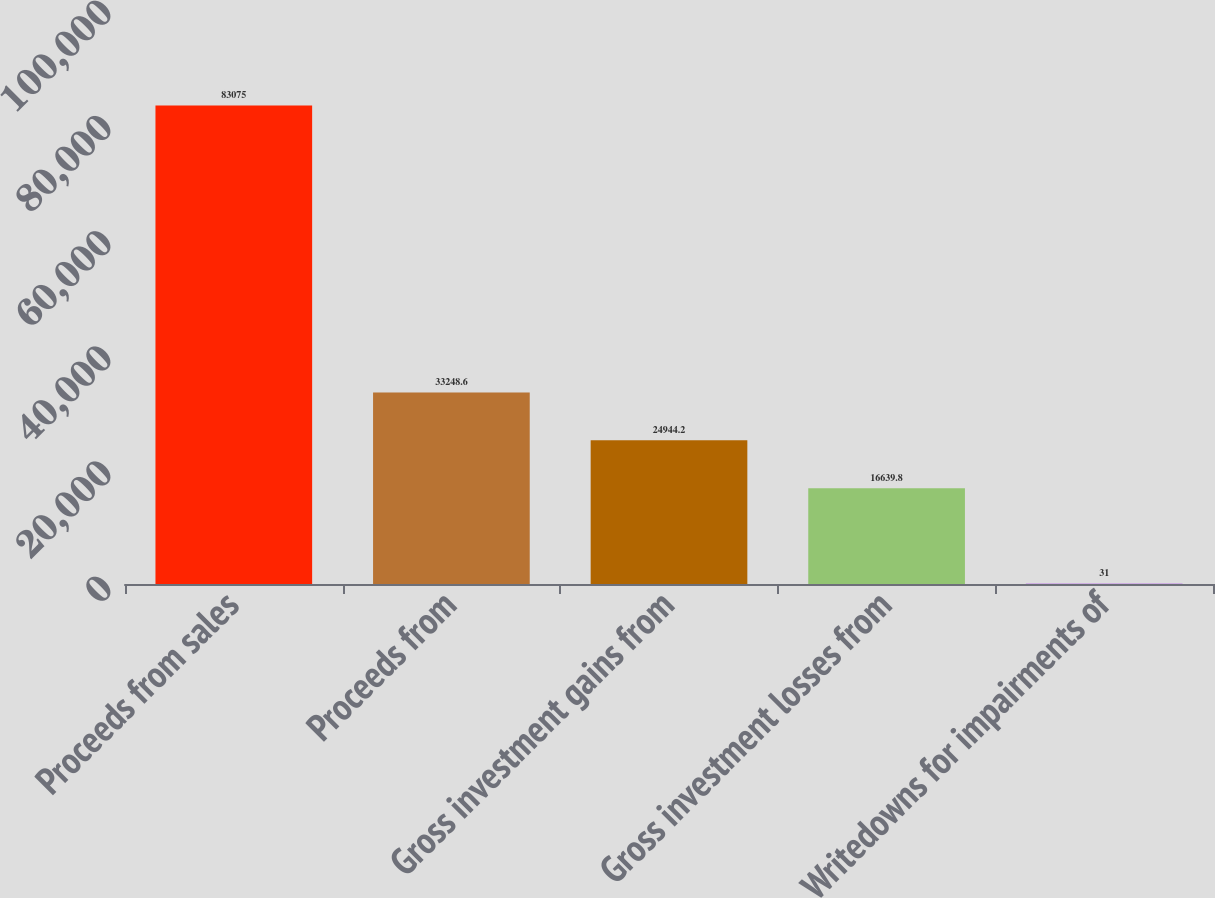Convert chart. <chart><loc_0><loc_0><loc_500><loc_500><bar_chart><fcel>Proceeds from sales<fcel>Proceeds from<fcel>Gross investment gains from<fcel>Gross investment losses from<fcel>Writedowns for impairments of<nl><fcel>83075<fcel>33248.6<fcel>24944.2<fcel>16639.8<fcel>31<nl></chart> 